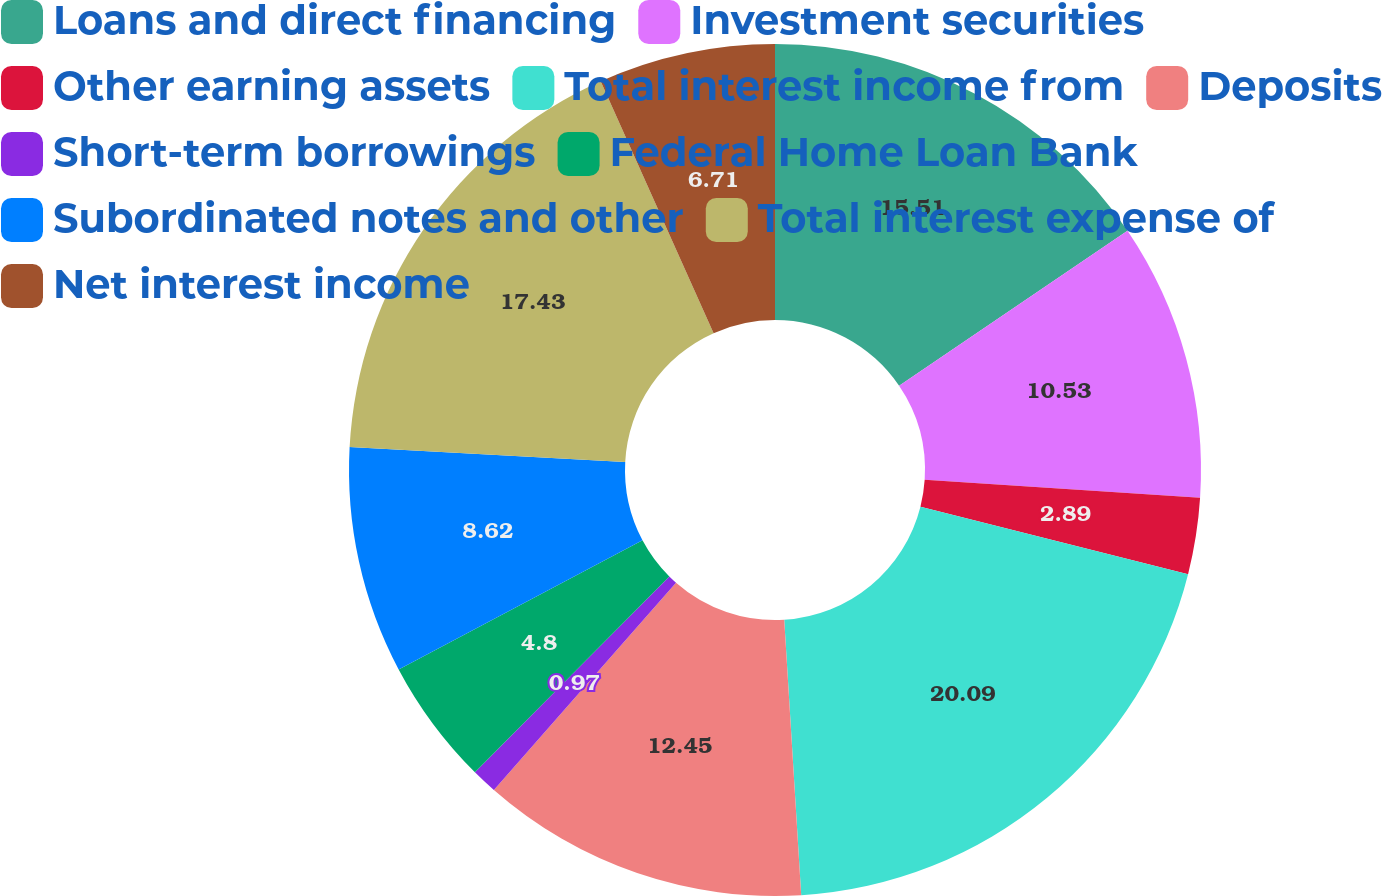<chart> <loc_0><loc_0><loc_500><loc_500><pie_chart><fcel>Loans and direct financing<fcel>Investment securities<fcel>Other earning assets<fcel>Total interest income from<fcel>Deposits<fcel>Short-term borrowings<fcel>Federal Home Loan Bank<fcel>Subordinated notes and other<fcel>Total interest expense of<fcel>Net interest income<nl><fcel>15.51%<fcel>10.53%<fcel>2.89%<fcel>20.09%<fcel>12.45%<fcel>0.97%<fcel>4.8%<fcel>8.62%<fcel>17.43%<fcel>6.71%<nl></chart> 